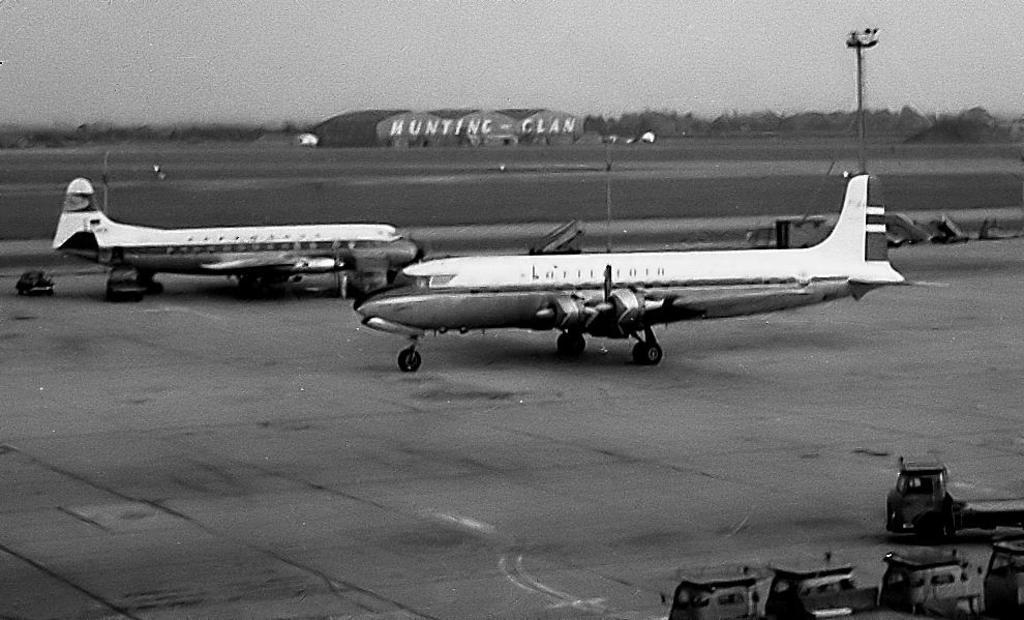What type of transportation can be seen on the ground in the image? There are airplanes on the ground in the image. What other vehicles are present in the image? There are vehicles beside the airplanes. What structures can be seen in the image? There are poles in the image. What can be seen in the background of the image? There are trees and buildings in the background of the image. Where is the rose garden located in the image? There is no rose garden present in the image. Is there a jail visible in the image? There is no jail visible in the image. 